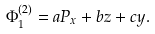Convert formula to latex. <formula><loc_0><loc_0><loc_500><loc_500>\Phi ^ { ( 2 ) } _ { 1 } = a P _ { x } + b z + c y .</formula> 